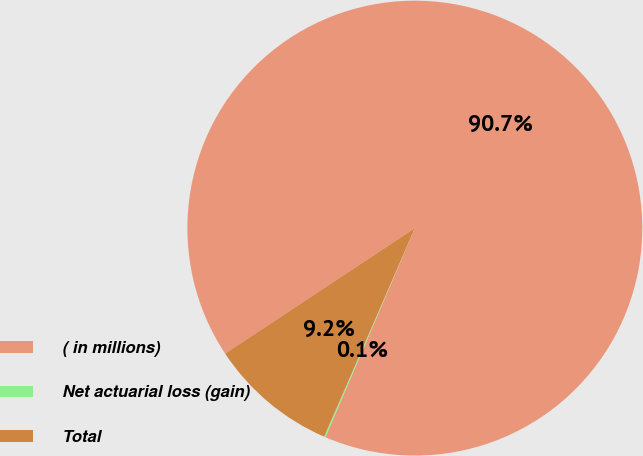Convert chart. <chart><loc_0><loc_0><loc_500><loc_500><pie_chart><fcel>( in millions)<fcel>Net actuarial loss (gain)<fcel>Total<nl><fcel>90.73%<fcel>0.1%<fcel>9.17%<nl></chart> 